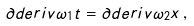Convert formula to latex. <formula><loc_0><loc_0><loc_500><loc_500>\partial d e r i v { \omega _ { 1 } } { t } = \partial d e r i v { \omega _ { 2 } } x \, ,</formula> 